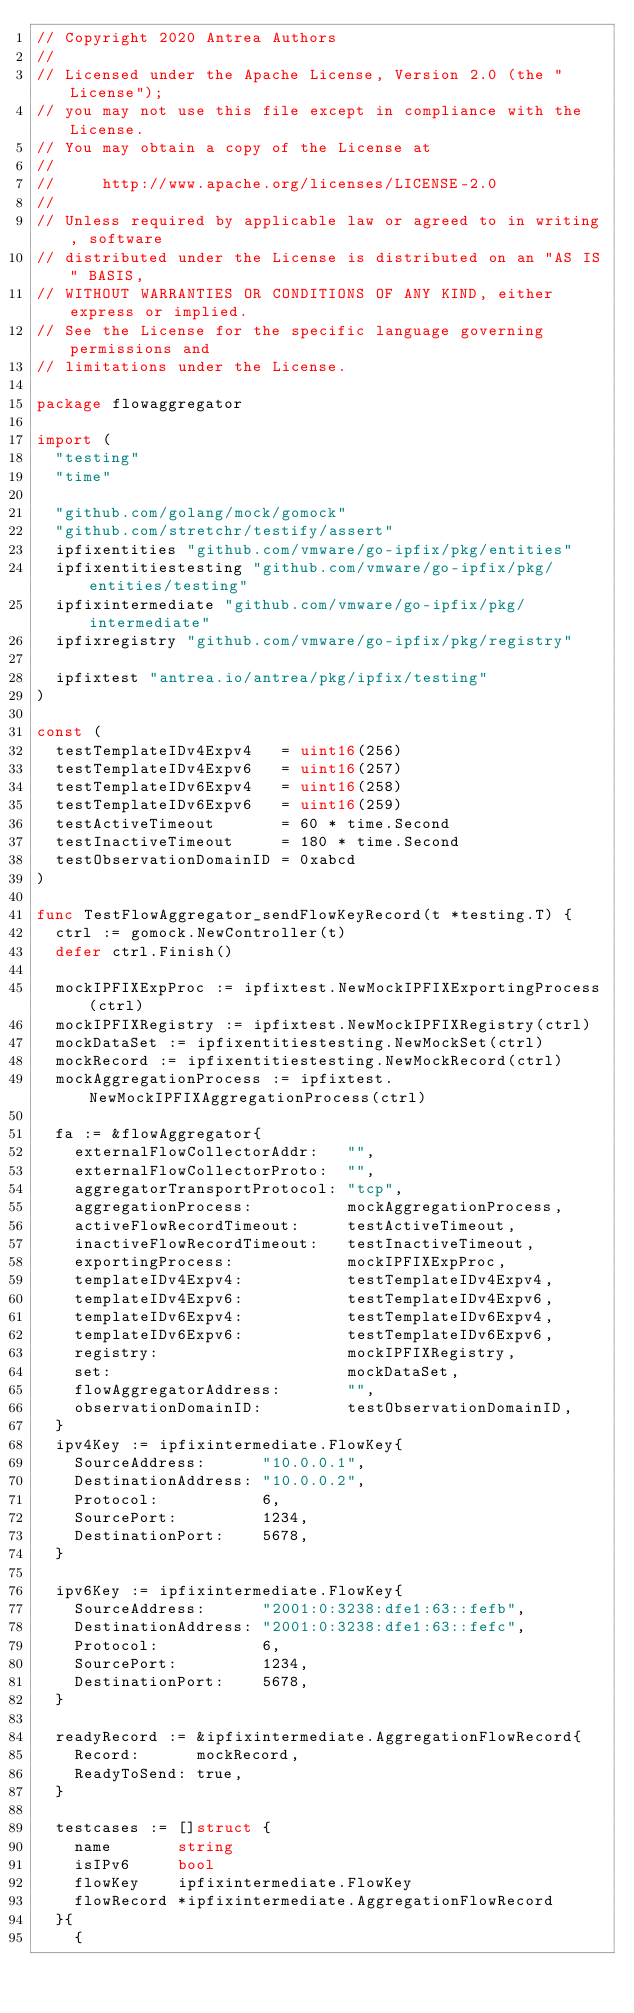<code> <loc_0><loc_0><loc_500><loc_500><_Go_>// Copyright 2020 Antrea Authors
//
// Licensed under the Apache License, Version 2.0 (the "License");
// you may not use this file except in compliance with the License.
// You may obtain a copy of the License at
//
//     http://www.apache.org/licenses/LICENSE-2.0
//
// Unless required by applicable law or agreed to in writing, software
// distributed under the License is distributed on an "AS IS" BASIS,
// WITHOUT WARRANTIES OR CONDITIONS OF ANY KIND, either express or implied.
// See the License for the specific language governing permissions and
// limitations under the License.

package flowaggregator

import (
	"testing"
	"time"

	"github.com/golang/mock/gomock"
	"github.com/stretchr/testify/assert"
	ipfixentities "github.com/vmware/go-ipfix/pkg/entities"
	ipfixentitiestesting "github.com/vmware/go-ipfix/pkg/entities/testing"
	ipfixintermediate "github.com/vmware/go-ipfix/pkg/intermediate"
	ipfixregistry "github.com/vmware/go-ipfix/pkg/registry"

	ipfixtest "antrea.io/antrea/pkg/ipfix/testing"
)

const (
	testTemplateIDv4Expv4   = uint16(256)
	testTemplateIDv4Expv6   = uint16(257)
	testTemplateIDv6Expv4   = uint16(258)
	testTemplateIDv6Expv6   = uint16(259)
	testActiveTimeout       = 60 * time.Second
	testInactiveTimeout     = 180 * time.Second
	testObservationDomainID = 0xabcd
)

func TestFlowAggregator_sendFlowKeyRecord(t *testing.T) {
	ctrl := gomock.NewController(t)
	defer ctrl.Finish()

	mockIPFIXExpProc := ipfixtest.NewMockIPFIXExportingProcess(ctrl)
	mockIPFIXRegistry := ipfixtest.NewMockIPFIXRegistry(ctrl)
	mockDataSet := ipfixentitiestesting.NewMockSet(ctrl)
	mockRecord := ipfixentitiestesting.NewMockRecord(ctrl)
	mockAggregationProcess := ipfixtest.NewMockIPFIXAggregationProcess(ctrl)

	fa := &flowAggregator{
		externalFlowCollectorAddr:   "",
		externalFlowCollectorProto:  "",
		aggregatorTransportProtocol: "tcp",
		aggregationProcess:          mockAggregationProcess,
		activeFlowRecordTimeout:     testActiveTimeout,
		inactiveFlowRecordTimeout:   testInactiveTimeout,
		exportingProcess:            mockIPFIXExpProc,
		templateIDv4Expv4:           testTemplateIDv4Expv4,
		templateIDv4Expv6:           testTemplateIDv4Expv6,
		templateIDv6Expv4:           testTemplateIDv6Expv4,
		templateIDv6Expv6:           testTemplateIDv6Expv6,
		registry:                    mockIPFIXRegistry,
		set:                         mockDataSet,
		flowAggregatorAddress:       "",
		observationDomainID:         testObservationDomainID,
	}
	ipv4Key := ipfixintermediate.FlowKey{
		SourceAddress:      "10.0.0.1",
		DestinationAddress: "10.0.0.2",
		Protocol:           6,
		SourcePort:         1234,
		DestinationPort:    5678,
	}

	ipv6Key := ipfixintermediate.FlowKey{
		SourceAddress:      "2001:0:3238:dfe1:63::fefb",
		DestinationAddress: "2001:0:3238:dfe1:63::fefc",
		Protocol:           6,
		SourcePort:         1234,
		DestinationPort:    5678,
	}

	readyRecord := &ipfixintermediate.AggregationFlowRecord{
		Record:      mockRecord,
		ReadyToSend: true,
	}

	testcases := []struct {
		name       string
		isIPv6     bool
		flowKey    ipfixintermediate.FlowKey
		flowRecord *ipfixintermediate.AggregationFlowRecord
	}{
		{</code> 